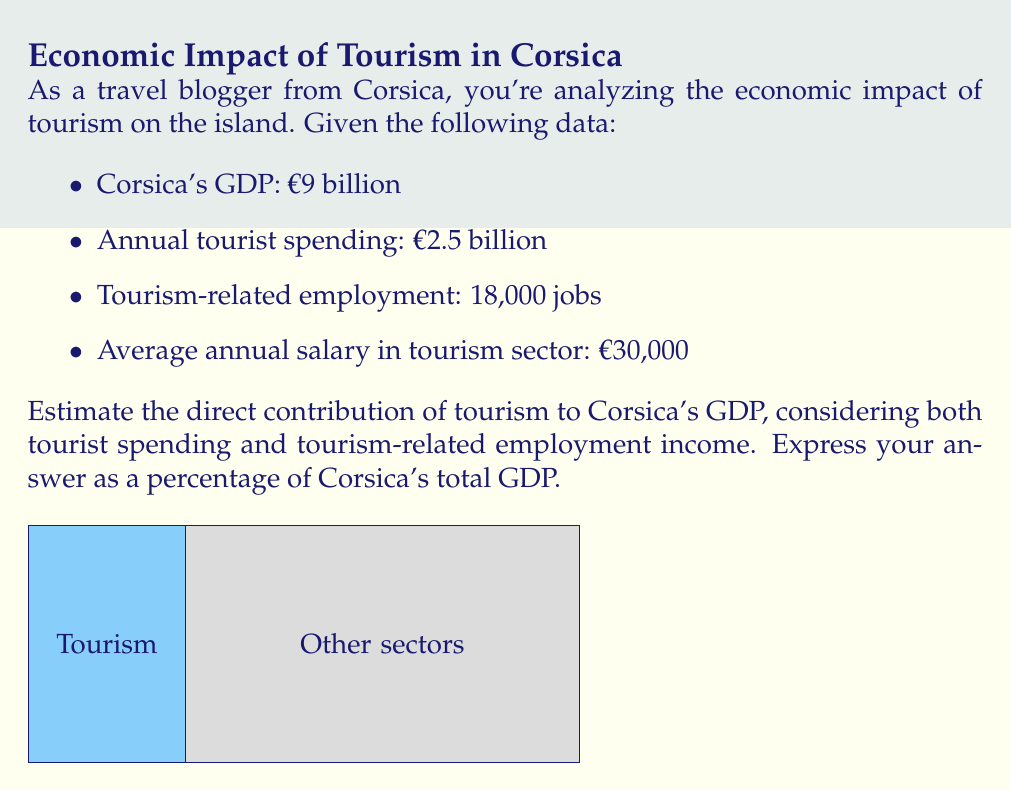Solve this math problem. Let's approach this step-by-step:

1) First, we need to calculate the total direct contribution of tourism to GDP. This includes:
   a) Tourist spending
   b) Income generated from tourism-related employment

2) Tourist spending is given: €2.5 billion

3) For tourism-related employment income:
   - Number of jobs: 18,000
   - Average annual salary: €30,000
   
   Total employment income = 18,000 × €30,000 = €540 million

4) Total direct contribution of tourism:
   $$\text{Total contribution} = \text{Tourist spending} + \text{Employment income}$$
   $$\text{Total contribution} = €2.5 \text{ billion} + €0.54 \text{ billion} = €3.04 \text{ billion}$$

5) To express this as a percentage of GDP:
   $$\text{Percentage of GDP} = \frac{\text{Tourism contribution}}{\text{Total GDP}} \times 100\%$$
   $$\text{Percentage of GDP} = \frac{€3.04 \text{ billion}}{€9 \text{ billion}} \times 100\% = 33.78\%$$

6) Rounding to two decimal places: 33.78%
Answer: 33.78% 